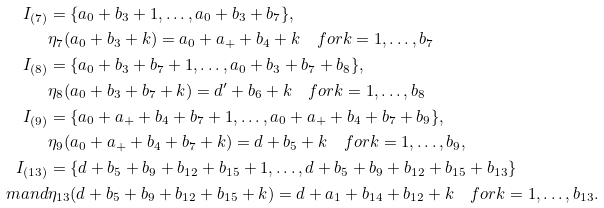<formula> <loc_0><loc_0><loc_500><loc_500>I _ { ( 7 ) } & = \{ a _ { 0 } + b _ { 3 } + 1 , \dots , a _ { 0 } + b _ { 3 } + b _ { 7 } \} , \\ & \eta _ { 7 } ( a _ { 0 } + b _ { 3 } + k ) = a _ { 0 } + a _ { + } + b _ { 4 } + k \quad f o r k = 1 , \dots , b _ { 7 } \\ I _ { ( 8 ) } & = \{ a _ { 0 } + b _ { 3 } + b _ { 7 } + 1 , \dots , a _ { 0 } + b _ { 3 } + b _ { 7 } + b _ { 8 } \} , \\ & \eta _ { 8 } ( a _ { 0 } + b _ { 3 } + b _ { 7 } + k ) = d ^ { \prime } + b _ { 6 } + k \quad f o r k = 1 , \dots , b _ { 8 } \\ I _ { ( 9 ) } & = \{ a _ { 0 } + a _ { + } + b _ { 4 } + b _ { 7 } + 1 , \dots , a _ { 0 } + a _ { + } + b _ { 4 } + b _ { 7 } + b _ { 9 } \} , \\ & \eta _ { 9 } ( a _ { 0 } + a _ { + } + b _ { 4 } + b _ { 7 } + k ) = d + b _ { 5 } + k \quad f o r k = 1 , \dots , b _ { 9 } , \\ I _ { ( 1 3 ) } & = \{ d + b _ { 5 } + b _ { 9 } + b _ { 1 2 } + b _ { 1 5 } + 1 , \dots , d + b _ { 5 } + b _ { 9 } + b _ { 1 2 } + b _ { 1 5 } + b _ { 1 3 } \} \\ \ m a n d & \eta _ { 1 3 } ( d + b _ { 5 } + b _ { 9 } + b _ { 1 2 } + b _ { 1 5 } + k ) = d + a _ { 1 } + b _ { 1 4 } + b _ { 1 2 } + k \quad f o r k = 1 , \dots , b _ { 1 3 } .</formula> 